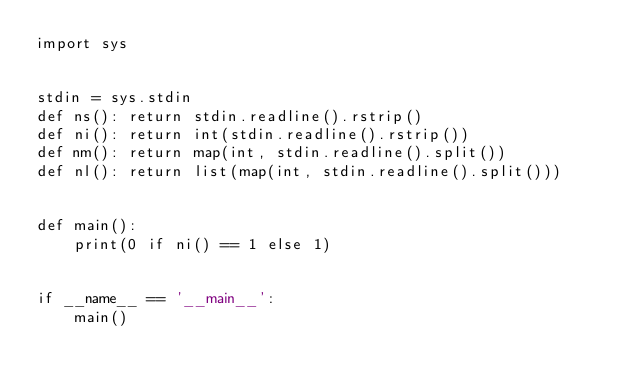Convert code to text. <code><loc_0><loc_0><loc_500><loc_500><_Python_>import sys


stdin = sys.stdin
def ns(): return stdin.readline().rstrip()
def ni(): return int(stdin.readline().rstrip())
def nm(): return map(int, stdin.readline().split())
def nl(): return list(map(int, stdin.readline().split()))


def main():
    print(0 if ni() == 1 else 1)


if __name__ == '__main__':
    main()
</code> 